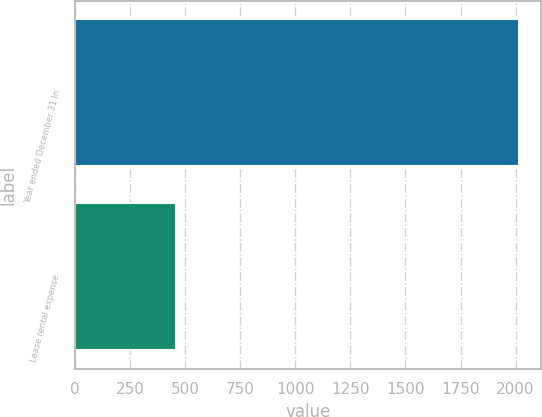<chart> <loc_0><loc_0><loc_500><loc_500><bar_chart><fcel>Year ended December 31 In<fcel>Lease rental expense<nl><fcel>2015<fcel>460<nl></chart> 